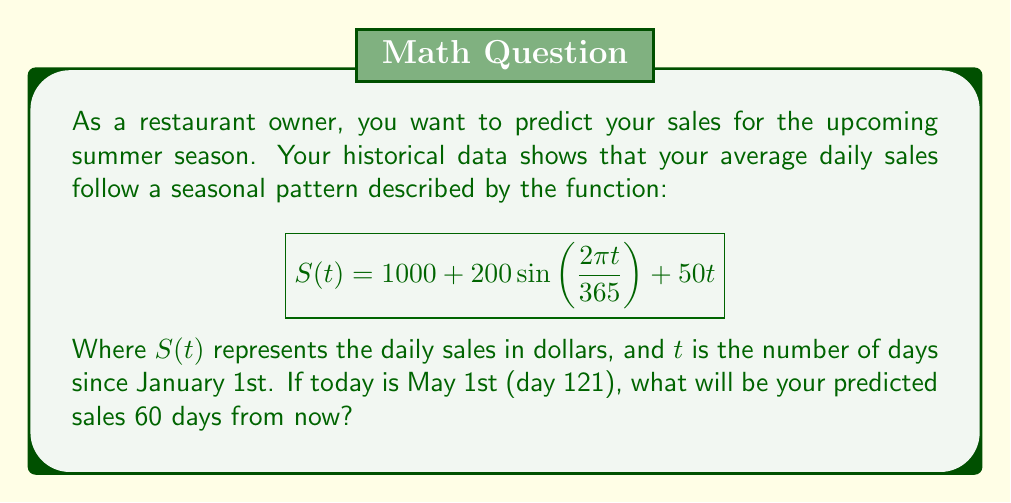Can you solve this math problem? To solve this problem, we need to follow these steps:

1. Identify the day for which we're predicting sales:
   May 1st is day 121, and we're predicting 60 days from now.
   So, $t = 121 + 60 = 181$

2. Plug this value of $t$ into the given function:

   $$S(181) = 1000 + 200\sin\left(\frac{2\pi \cdot 181}{365}\right) + 50 \cdot 181$$

3. Let's break this down:
   
   a) The constant term: $1000$
   
   b) The seasonal term: $200\sin\left(\frac{2\pi \cdot 181}{365}\right)$
      $$200\sin\left(\frac{2\pi \cdot 181}{365}\right) \approx 200 \cdot 0.8910 = 178.20$$
   
   c) The linear growth term: $50 \cdot 181 = 9050$

4. Now, let's sum up all these terms:

   $$S(181) = 1000 + 178.20 + 9050 = 10,228.20$$

Therefore, the predicted sales 60 days from May 1st will be approximately $10,228.20.
Answer: $10,228.20 